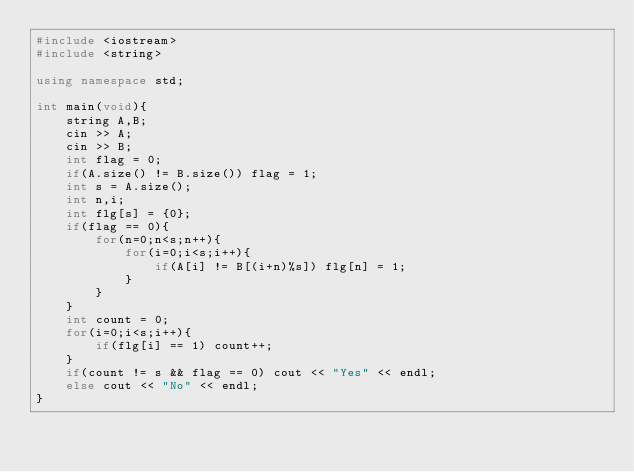Convert code to text. <code><loc_0><loc_0><loc_500><loc_500><_C++_>#include <iostream>
#include <string>

using namespace std;

int main(void){
	string A,B;
	cin >> A;
	cin >> B;
	int flag = 0;
	if(A.size() != B.size()) flag = 1;
	int s = A.size();
	int n,i;
	int flg[s] = {0};
	if(flag == 0){
		for(n=0;n<s;n++){
			for(i=0;i<s;i++){
				if(A[i] != B[(i+n)%s]) flg[n] = 1; 
			}
		}
	}
	int count = 0;
	for(i=0;i<s;i++){
		if(flg[i] == 1) count++;
	}
	if(count != s && flag == 0) cout << "Yes" << endl;
	else cout << "No" << endl;
}</code> 